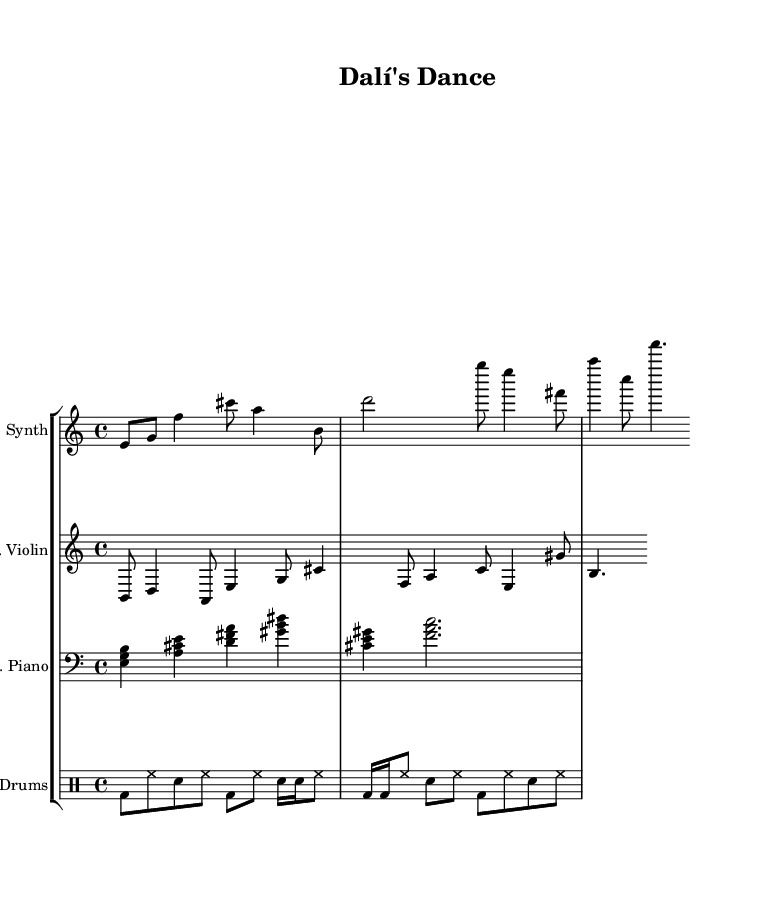What is the time signature of this music? The time signature is displayed at the beginning of the score as 4/4, indicating four beats per measure.
Answer: 4/4 What is the clef used for the main theme? The clef for the main theme is indicated as treble, shown at the beginning of the staff.
Answer: Treble How many voices are present in this piece? The score consists of four distinct staves representing three different instruments, indicating a total of four voices.
Answer: Four Which instrument plays the counter melody? The counter melody is notated on the staff labeled "E. Violin," showing that this instrument performs that part.
Answer: E. Violin What is the first note of the main theme? The first note of the main theme corresponds to the note E, shown as the first note in the mainTheme section.
Answer: E What type of rhythm pattern is used in the drum part? The drum part uses a combination of bass drums, hi-hats, and snare drums, indicated through different notation patterns in the provided measures.
Answer: Mixed rhythm How does the piece transition dynamics between sections? The dynamics can be inferred through the differing note values and instruments, showing that there may be changes in intensity throughout the piece.
Answer: Variable dynamics 